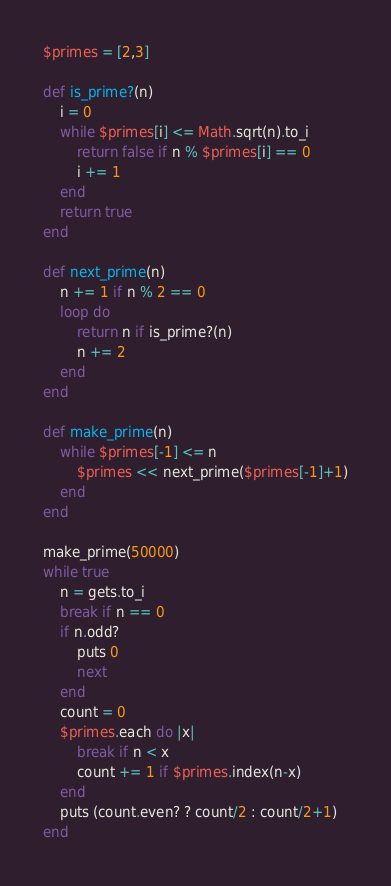<code> <loc_0><loc_0><loc_500><loc_500><_Ruby_>$primes = [2,3]

def is_prime?(n)
	i = 0
	while $primes[i] <= Math.sqrt(n).to_i
		return false if n % $primes[i] == 0
		i += 1
	end
	return true
end

def next_prime(n)
	n += 1 if n % 2 == 0
	loop do
		return n if is_prime?(n)
		n += 2
	end
end

def make_prime(n)
	while $primes[-1] <= n
		$primes << next_prime($primes[-1]+1)
	end
end

make_prime(50000)
while true
	n = gets.to_i
	break if n == 0
	if n.odd?
		puts 0
		next
	end
	count = 0
	$primes.each do |x| 
		break if n < x
		count += 1 if $primes.index(n-x)
	end
	puts (count.even? ? count/2 : count/2+1)
end</code> 